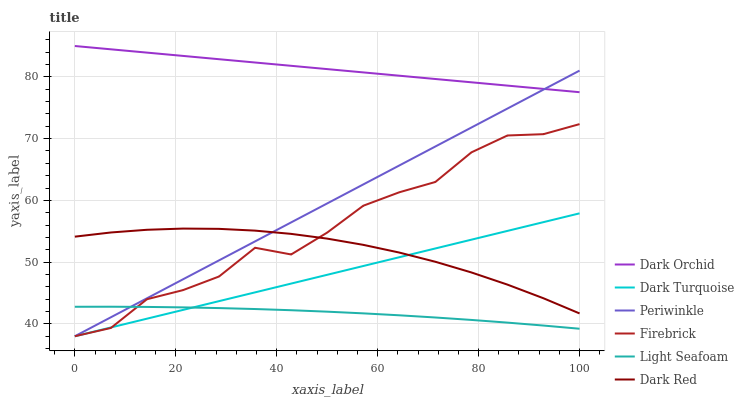Does Firebrick have the minimum area under the curve?
Answer yes or no. No. Does Firebrick have the maximum area under the curve?
Answer yes or no. No. Is Dark Orchid the smoothest?
Answer yes or no. No. Is Dark Orchid the roughest?
Answer yes or no. No. Does Dark Orchid have the lowest value?
Answer yes or no. No. Does Firebrick have the highest value?
Answer yes or no. No. Is Dark Turquoise less than Dark Orchid?
Answer yes or no. Yes. Is Dark Red greater than Light Seafoam?
Answer yes or no. Yes. Does Dark Turquoise intersect Dark Orchid?
Answer yes or no. No. 